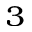<formula> <loc_0><loc_0><loc_500><loc_500>^ { 3 }</formula> 